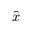<formula> <loc_0><loc_0><loc_500><loc_500>\hat { x }</formula> 